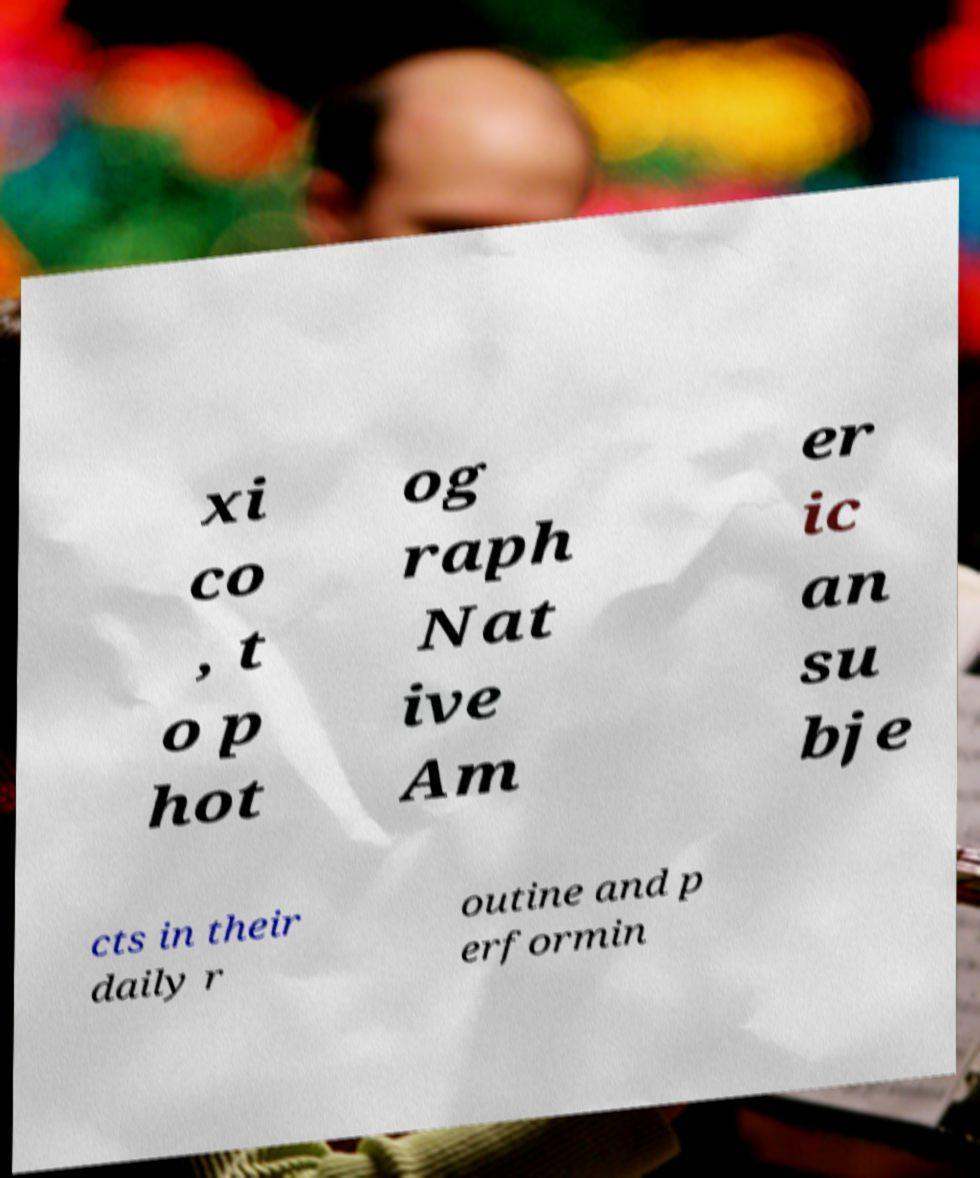Please identify and transcribe the text found in this image. xi co , t o p hot og raph Nat ive Am er ic an su bje cts in their daily r outine and p erformin 